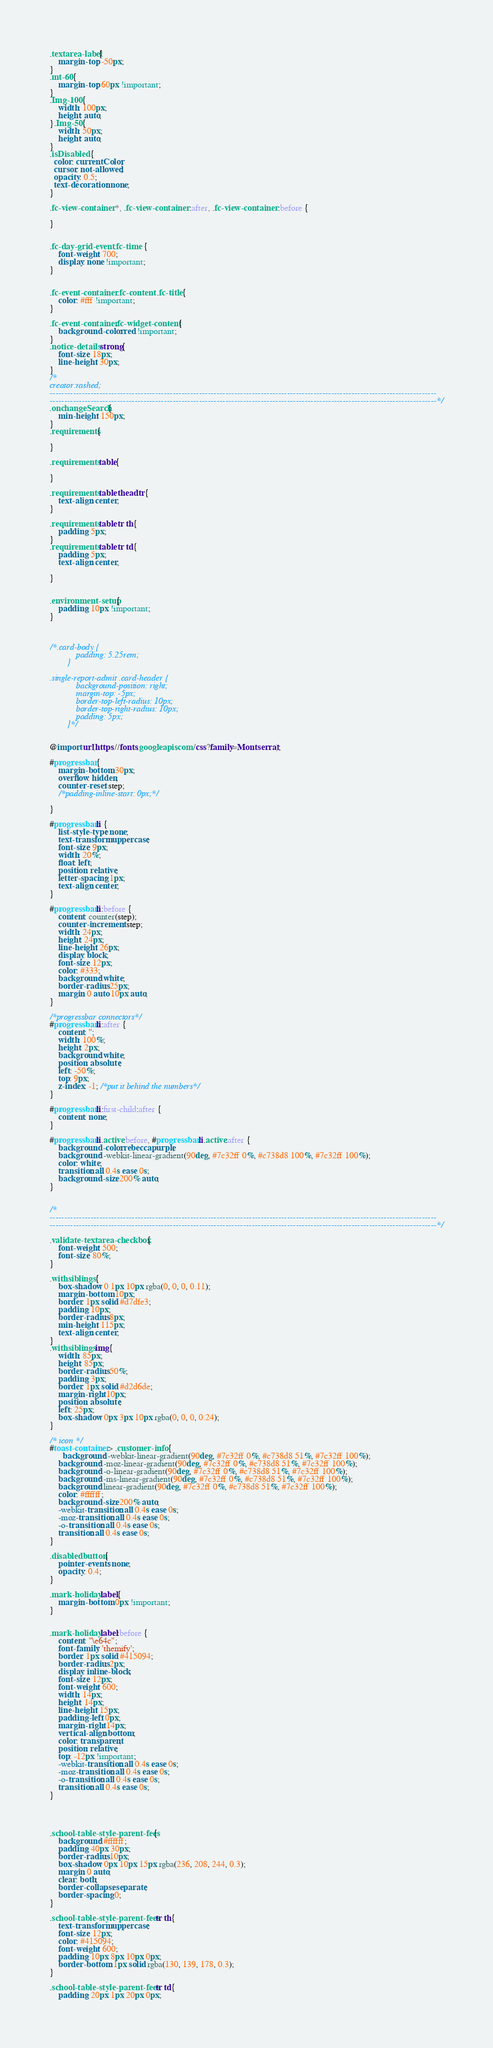Convert code to text. <code><loc_0><loc_0><loc_500><loc_500><_CSS_>.textarea-label{
    margin-top: -50px;
}
.mt-60{
    margin-top: 60px !important;
}
.Img-100{
    width: 100px;
    height: auto;
}.Img-50{
    width: 50px;
    height: auto;
}
.isDisabled {
  color: currentColor;
  cursor: not-allowed;
  opacity: 0.5;
  text-decoration: none;
}

.fc-view-container *, .fc-view-container :after, .fc-view-container :before {

}


.fc-day-grid-event .fc-time {
    font-weight: 700;
    display: none !important;
}


.fc-event-container .fc-content .fc-title{
    color: #fff !important;
}

.fc-event-container.fc-widget-content{
    background-color: red !important;
}
.notice-details strong{
    font-size: 18px;
    line-height: 30px;
}
/*
creator:rashed;
------------------------------------------------------------------------------------------------------------------------------------
------------------------------------------------------------------------------------------------------------------------------------*/
.onchangeSearch{
    min-height: 150px;
}
.requirements{

}

.requirements table{

}

.requirements table thead tr{
    text-align: center;
}

.requirements table tr th{
    padding: 5px;
}
.requirements table tr td{
    padding: 5px;
    text-align: center;

}


.environment-setup{
    padding: 10px !important;
}



/*.card-body {
            padding: 5.25rem;
        }

.single-report-admit .card-header {
            background-position: right;
            margin-top: -5px;
            border-top-left-radius: 10px;
            border-top-right-radius: 10px;
            padding: 5px;
        }*/


@import url(https://fonts.googleapis.com/css?family=Montserrat);

#progressbar {
    margin-bottom: 30px;
    overflow: hidden;
    counter-reset: step;
    /*padding-inline-start: 0px;*/

}

#progressbar li {
    list-style-type: none;
    text-transform: uppercase;
    font-size: 9px;
    width: 20%;
    float: left;
    position: relative;
    letter-spacing: 1px;
    text-align: center;
}

#progressbar li:before {
    content: counter(step);
    counter-increment: step;
    width: 24px;
    height: 24px;
    line-height: 26px;
    display: block;
    font-size: 12px;
    color: #333;
    background: white;
    border-radius: 25px;
    margin: 0 auto 10px auto;
}

/*progressbar connectors*/
#progressbar li:after {
    content: '';
    width: 100%;
    height: 2px;
    background: white;
    position: absolute;
    left: -50%;
    top: 9px;
    z-index: -1; /*put it behind the numbers*/
}

#progressbar li:first-child:after {
    content: none;
}

#progressbar li.active:before, #progressbar li.active:after {
    background-color: rebeccapurple;
    background: -webkit-linear-gradient(90deg, #7c32ff 0%, #c738d8 100%, #7c32ff 100%);
    color: white;
    transition: all 0.4s ease 0s;
    background-size: 200% auto;
}


/*
------------------------------------------------------------------------------------------------------------------------------------
------------------------------------------------------------------------------------------------------------------------------------*/

.validate-textarea-checkbox {
    font-weight: 500;
    font-size: 80%;
}

.withsiblings {
    box-shadow: 0 1px 10px rgba(0, 0, 0, 0.11);
    margin-bottom: 10px;
    border: 1px solid #d7dfe3;
    padding: 10px;
    border-radius: 8px;
    min-height: 115px;
    text-align: center;
}
.withsiblings img{
	width: 85px;
    height: 85px;
    border-radius: 50%;
    padding: 3px;
    border: 1px solid #d2d6de;
    margin-right: 10px;
    position: absolute;
    left: 25px;
    box-shadow: 0px 3px 10px rgba(0, 0, 0, 0.24);
}

/* icon */
#toast-container > .customer-info {
      background: -webkit-linear-gradient(90deg, #7c32ff 0%, #c738d8 51%, #7c32ff 100%);
    background: -moz-linear-gradient(90deg, #7c32ff 0%, #c738d8 51%, #7c32ff 100%);
    background: -o-linear-gradient(90deg, #7c32ff 0%, #c738d8 51%, #7c32ff 100%);
    background: -ms-linear-gradient(90deg, #7c32ff 0%, #c738d8 51%, #7c32ff 100%);
    background: linear-gradient(90deg, #7c32ff 0%, #c738d8 51%, #7c32ff 100%);
    color: #ffffff;
    background-size: 200% auto;
    -webkit-transition: all 0.4s ease 0s;
    -moz-transition: all 0.4s ease 0s;
    -o-transition: all 0.4s ease 0s;
    transition: all 0.4s ease 0s;
}

.disabledbutton {
    pointer-events: none;
    opacity: 0.4;
}

.mark-holiday label{
    margin-bottom: 0px !important;
}


.mark-holiday label:before {
    content: "\e64c";
    font-family: 'themify';
    border: 1px solid #415094;
    border-radius: 2px;
    display: inline-block;
    font-size: 12px;
    font-weight: 600;
    width: 14px;
    height: 14px;
    line-height: 15px;
    padding-left: 0px;
    margin-right: 14px;
    vertical-align: bottom;
    color: transparent;
    position: relative;
    top: -12px !important;
    -webkit-transition: all 0.4s ease 0s;
    -moz-transition: all 0.4s ease 0s;
    -o-transition: all 0.4s ease 0s;
    transition: all 0.4s ease 0s;
}




.school-table-style-parent-fees{
    background: #ffffff;
    padding: 40px 30px;
    border-radius: 10px;
    box-shadow: 0px 10px 15px rgba(236, 208, 244, 0.3);
    margin: 0 auto;
    clear: both;
    border-collapse: separate;
    border-spacing: 0;
}

.school-table-style-parent-fees tr th{
    text-transform: uppercase;
    font-size: 12px;
    color: #415094;
    font-weight: 600;
    padding: 10px 8px 10px 0px;
    border-bottom: 1px solid rgba(130, 139, 178, 0.3);
}

.school-table-style-parent-fees tr td{
    padding: 20px 1px 20px 0px;</code> 